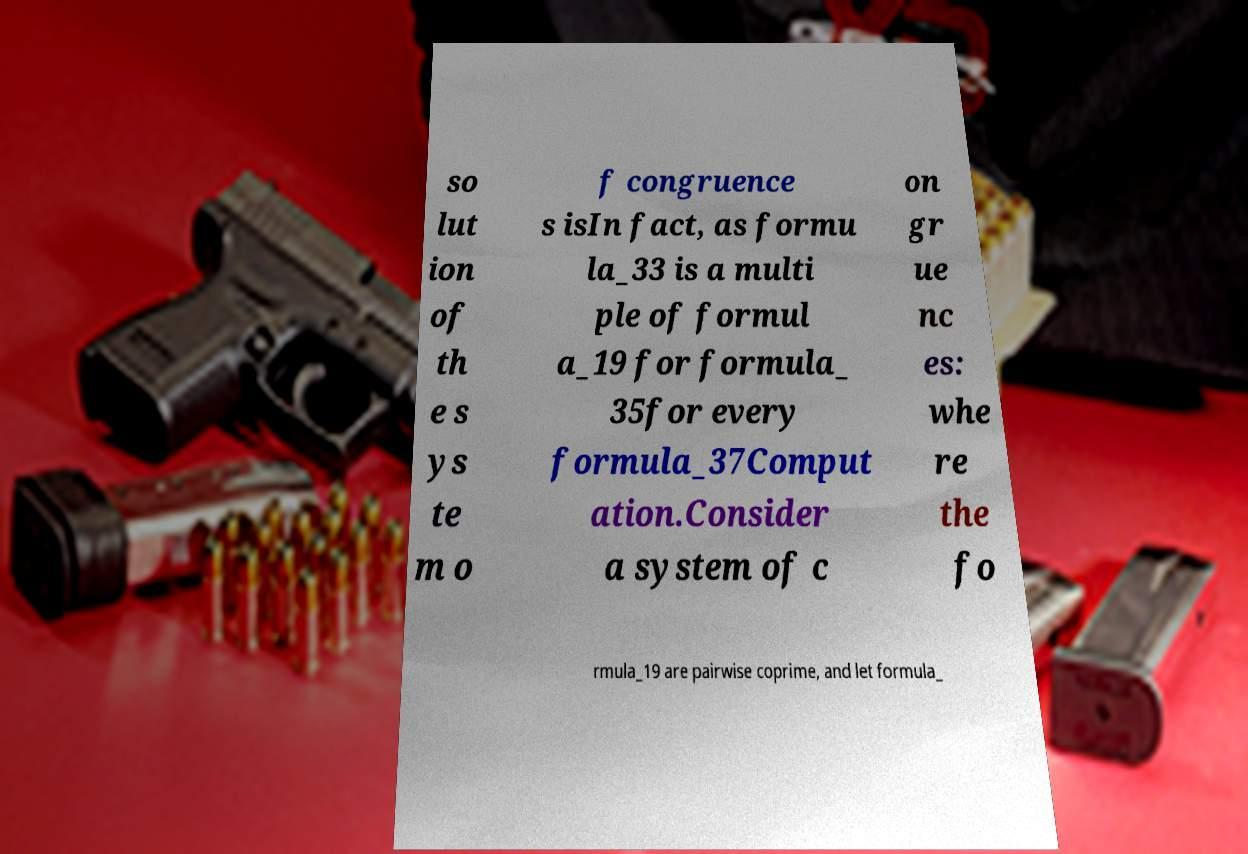Can you accurately transcribe the text from the provided image for me? so lut ion of th e s ys te m o f congruence s isIn fact, as formu la_33 is a multi ple of formul a_19 for formula_ 35for every formula_37Comput ation.Consider a system of c on gr ue nc es: whe re the fo rmula_19 are pairwise coprime, and let formula_ 